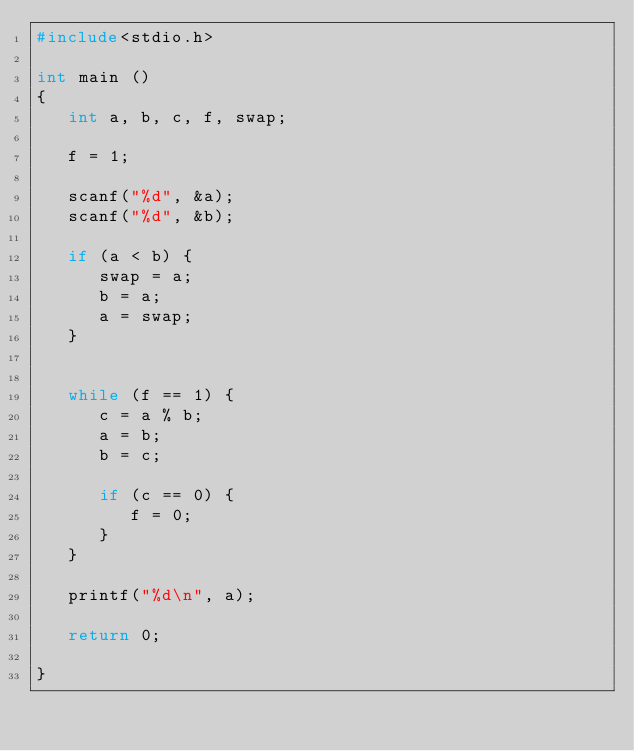<code> <loc_0><loc_0><loc_500><loc_500><_C_>#include<stdio.h>

int main () 
{
   int a, b, c, f, swap;

   f = 1;

   scanf("%d", &a);
   scanf("%d", &b);

   if (a < b) {
      swap = a;
      b = a;
      a = swap;
   }


   while (f == 1) {
      c = a % b;
      a = b;
      b = c;

      if (c == 0) {
         f = 0;
      }
   }

   printf("%d\n", a);

   return 0;

}</code> 